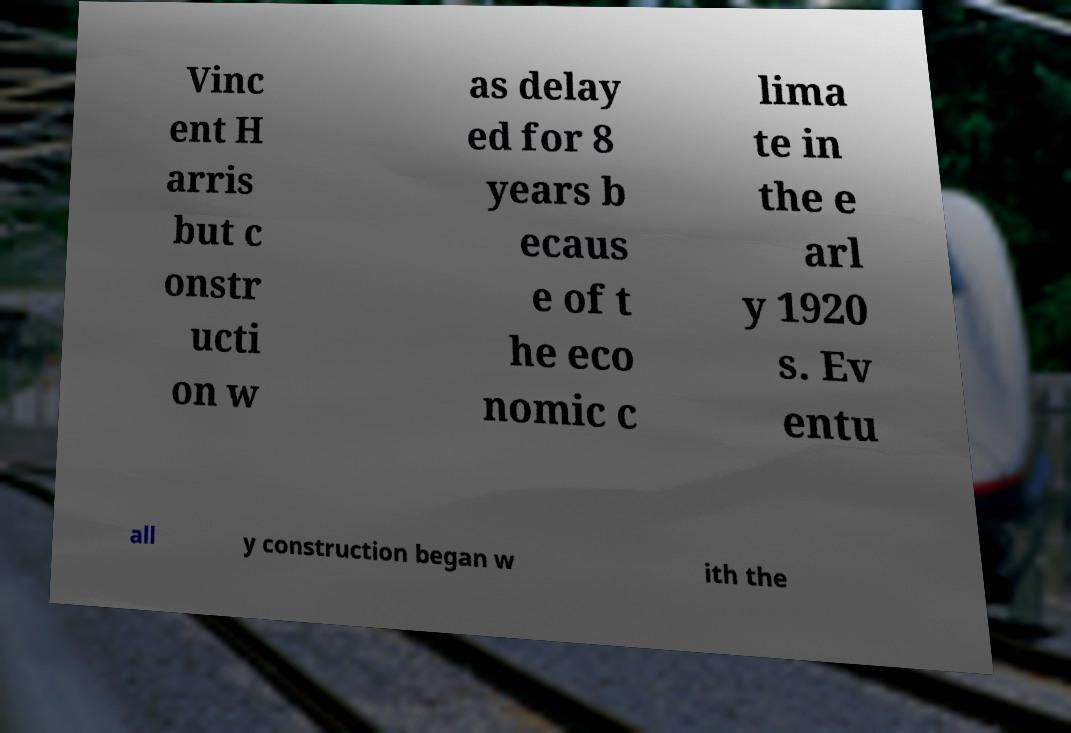What messages or text are displayed in this image? I need them in a readable, typed format. Vinc ent H arris but c onstr ucti on w as delay ed for 8 years b ecaus e of t he eco nomic c lima te in the e arl y 1920 s. Ev entu all y construction began w ith the 